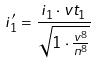<formula> <loc_0><loc_0><loc_500><loc_500>i _ { 1 } ^ { \prime } = \frac { i _ { 1 } \cdot v t _ { 1 } } { \sqrt { 1 \cdot \frac { v ^ { 8 } } { n ^ { 8 } } } }</formula> 